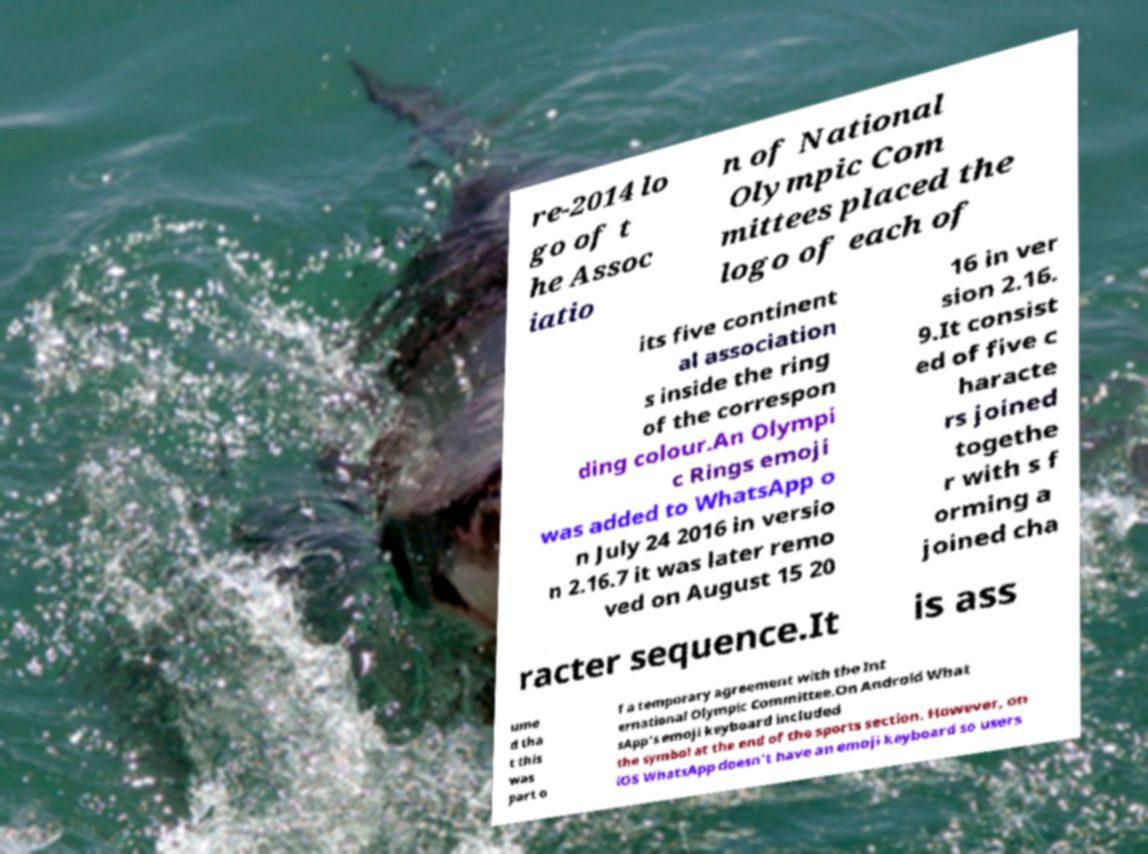Could you extract and type out the text from this image? re-2014 lo go of t he Assoc iatio n of National Olympic Com mittees placed the logo of each of its five continent al association s inside the ring of the correspon ding colour.An Olympi c Rings emoji was added to WhatsApp o n July 24 2016 in versio n 2.16.7 it was later remo ved on August 15 20 16 in ver sion 2.16. 9.It consist ed of five c haracte rs joined togethe r with s f orming a joined cha racter sequence.It is ass ume d tha t this was part o f a temporary agreement with the Int ernational Olympic Committee.On Android What sApp's emoji keyboard included the symbol at the end of the sports section. However, on iOS WhatsApp doesn't have an emoji keyboard so users 